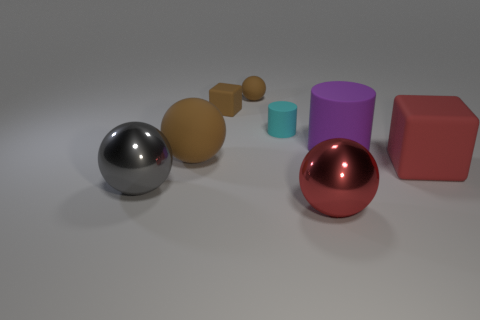Are there more brown balls behind the purple cylinder than big gray shiny things that are behind the big gray metal ball?
Give a very brief answer. Yes. Are there any purple things of the same shape as the tiny cyan object?
Keep it short and to the point. Yes. What shape is the brown rubber object that is the same size as the purple cylinder?
Give a very brief answer. Sphere. There is a red object that is behind the red sphere; what shape is it?
Make the answer very short. Cube. Is the number of blocks on the left side of the large brown sphere less than the number of small matte spheres that are in front of the large red shiny thing?
Provide a short and direct response. No. Is the size of the red block the same as the rubber ball in front of the purple matte object?
Ensure brevity in your answer.  Yes. How many brown cubes have the same size as the red shiny sphere?
Make the answer very short. 0. The small ball that is made of the same material as the big cylinder is what color?
Your answer should be compact. Brown. Is the number of large gray balls greater than the number of red objects?
Keep it short and to the point. No. Do the purple thing and the red sphere have the same material?
Keep it short and to the point. No. 